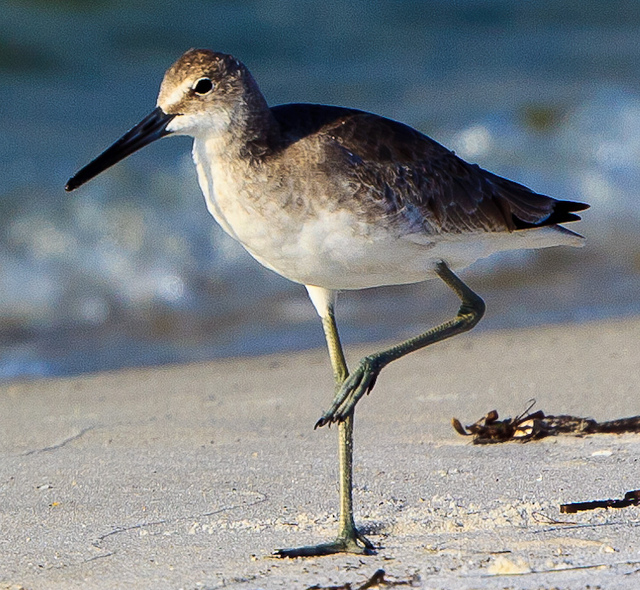<image>What type of animal is this? I am not sure what type of animal this is. It could be a pelican, sandpiper or another type of bird. What type of animal is this? I don't know what type of animal is this. It can be a pelican, sandpiper or some other bird. 